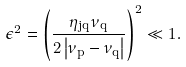<formula> <loc_0><loc_0><loc_500><loc_500>\epsilon ^ { 2 } = \left ( \frac { \eta _ { j q } \nu _ { q } } { 2 \left | \nu _ { p } - \nu _ { q } \right | } \right ) ^ { 2 } \ll 1 .</formula> 